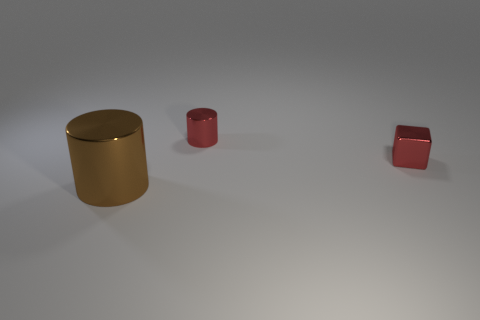There is a shiny block that is the same color as the small cylinder; what size is it?
Make the answer very short. Small. The small metal thing that is the same shape as the big brown shiny object is what color?
Provide a short and direct response. Red. What number of blocks are the same color as the small cylinder?
Keep it short and to the point. 1. How many objects are metallic cylinders that are right of the big shiny cylinder or green cylinders?
Give a very brief answer. 1. There is a metal cylinder on the right side of the big shiny thing; what is its size?
Your response must be concise. Small. Are there fewer large cyan shiny spheres than brown cylinders?
Ensure brevity in your answer.  Yes. Is the material of the object that is behind the metal block the same as the cylinder that is in front of the tiny red cube?
Offer a terse response. Yes. What is the shape of the red metal thing that is on the left side of the small red thing right of the cylinder to the right of the brown shiny object?
Your response must be concise. Cylinder. What number of objects have the same material as the brown cylinder?
Provide a short and direct response. 2. There is a cylinder behind the brown metal object; what number of small red cylinders are in front of it?
Provide a short and direct response. 0. 